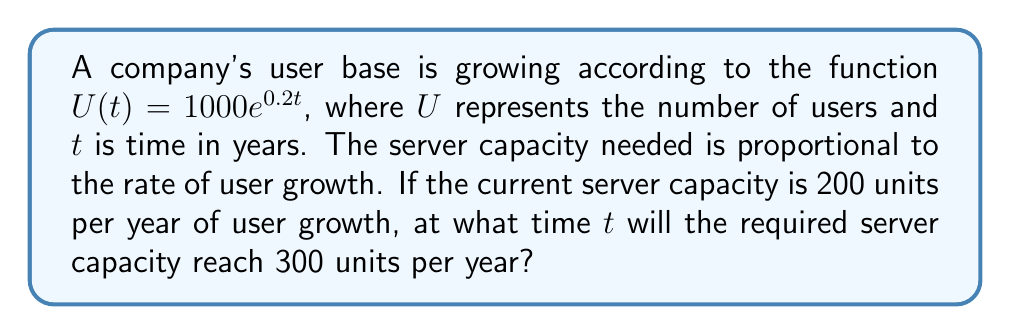Solve this math problem. To solve this problem, we need to follow these steps:

1) First, we need to find the rate of user growth. This is given by the derivative of $U(t)$:
   $$U'(t) = \frac{d}{dt}(1000e^{0.2t}) = 200e^{0.2t}$$

2) We're told that the server capacity needed is proportional to this rate. Currently, the capacity is 200 units when $U'(t) = 200e^{0.2t}$. This means the capacity $C$ is equal to $U'(t)$.

3) We need to find when $C = 300$. This means:
   $$300 = 200e^{0.2t}$$

4) Divide both sides by 200:
   $$1.5 = e^{0.2t}$$

5) Take the natural log of both sides:
   $$\ln(1.5) = 0.2t$$

6) Solve for $t$:
   $$t = \frac{\ln(1.5)}{0.2} \approx 2.03$$

Therefore, the required server capacity will reach 300 units per year after approximately 2.03 years.
Answer: $t \approx 2.03$ years 